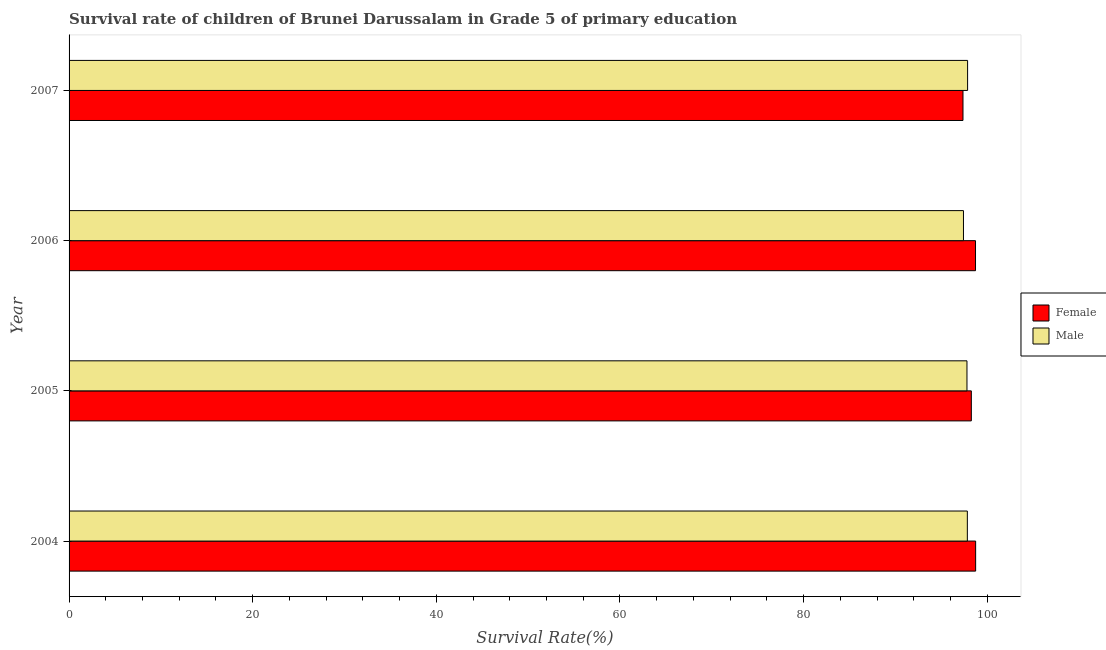How many different coloured bars are there?
Give a very brief answer. 2. In how many cases, is the number of bars for a given year not equal to the number of legend labels?
Your response must be concise. 0. What is the survival rate of female students in primary education in 2004?
Offer a very short reply. 98.74. Across all years, what is the maximum survival rate of male students in primary education?
Offer a very short reply. 97.86. Across all years, what is the minimum survival rate of female students in primary education?
Your answer should be compact. 97.36. In which year was the survival rate of male students in primary education minimum?
Make the answer very short. 2006. What is the total survival rate of male students in primary education in the graph?
Offer a terse response. 390.9. What is the difference between the survival rate of female students in primary education in 2004 and that in 2005?
Make the answer very short. 0.47. What is the difference between the survival rate of male students in primary education in 2006 and the survival rate of female students in primary education in 2005?
Make the answer very short. -0.86. What is the average survival rate of male students in primary education per year?
Give a very brief answer. 97.72. In the year 2007, what is the difference between the survival rate of female students in primary education and survival rate of male students in primary education?
Offer a very short reply. -0.5. In how many years, is the survival rate of female students in primary education greater than 84 %?
Offer a terse response. 4. What is the ratio of the survival rate of male students in primary education in 2004 to that in 2005?
Your response must be concise. 1. Is the survival rate of male students in primary education in 2006 less than that in 2007?
Your response must be concise. Yes. What is the difference between the highest and the second highest survival rate of female students in primary education?
Offer a very short reply. 0.01. What is the difference between the highest and the lowest survival rate of male students in primary education?
Your answer should be compact. 0.45. In how many years, is the survival rate of female students in primary education greater than the average survival rate of female students in primary education taken over all years?
Your answer should be compact. 2. What does the 2nd bar from the top in 2006 represents?
Ensure brevity in your answer.  Female. What does the 1st bar from the bottom in 2006 represents?
Offer a terse response. Female. How many bars are there?
Keep it short and to the point. 8. Are all the bars in the graph horizontal?
Give a very brief answer. Yes. How many years are there in the graph?
Give a very brief answer. 4. What is the difference between two consecutive major ticks on the X-axis?
Keep it short and to the point. 20. Does the graph contain grids?
Offer a terse response. No. How many legend labels are there?
Your answer should be compact. 2. What is the title of the graph?
Offer a very short reply. Survival rate of children of Brunei Darussalam in Grade 5 of primary education. Does "Secondary" appear as one of the legend labels in the graph?
Offer a terse response. No. What is the label or title of the X-axis?
Provide a succinct answer. Survival Rate(%). What is the label or title of the Y-axis?
Your answer should be very brief. Year. What is the Survival Rate(%) of Female in 2004?
Offer a terse response. 98.74. What is the Survival Rate(%) in Male in 2004?
Provide a succinct answer. 97.83. What is the Survival Rate(%) of Female in 2005?
Make the answer very short. 98.27. What is the Survival Rate(%) of Male in 2005?
Offer a very short reply. 97.79. What is the Survival Rate(%) in Female in 2006?
Provide a succinct answer. 98.72. What is the Survival Rate(%) of Male in 2006?
Your answer should be very brief. 97.41. What is the Survival Rate(%) in Female in 2007?
Your answer should be compact. 97.36. What is the Survival Rate(%) of Male in 2007?
Offer a very short reply. 97.86. Across all years, what is the maximum Survival Rate(%) in Female?
Your answer should be compact. 98.74. Across all years, what is the maximum Survival Rate(%) of Male?
Provide a succinct answer. 97.86. Across all years, what is the minimum Survival Rate(%) in Female?
Your response must be concise. 97.36. Across all years, what is the minimum Survival Rate(%) of Male?
Provide a succinct answer. 97.41. What is the total Survival Rate(%) of Female in the graph?
Your response must be concise. 393.09. What is the total Survival Rate(%) in Male in the graph?
Ensure brevity in your answer.  390.9. What is the difference between the Survival Rate(%) of Female in 2004 and that in 2005?
Provide a short and direct response. 0.47. What is the difference between the Survival Rate(%) of Male in 2004 and that in 2005?
Make the answer very short. 0.04. What is the difference between the Survival Rate(%) of Female in 2004 and that in 2006?
Offer a terse response. 0.01. What is the difference between the Survival Rate(%) in Male in 2004 and that in 2006?
Keep it short and to the point. 0.42. What is the difference between the Survival Rate(%) of Female in 2004 and that in 2007?
Offer a very short reply. 1.38. What is the difference between the Survival Rate(%) of Male in 2004 and that in 2007?
Your response must be concise. -0.03. What is the difference between the Survival Rate(%) of Female in 2005 and that in 2006?
Keep it short and to the point. -0.46. What is the difference between the Survival Rate(%) in Male in 2005 and that in 2006?
Your response must be concise. 0.38. What is the difference between the Survival Rate(%) in Female in 2005 and that in 2007?
Keep it short and to the point. 0.91. What is the difference between the Survival Rate(%) in Male in 2005 and that in 2007?
Offer a very short reply. -0.07. What is the difference between the Survival Rate(%) of Female in 2006 and that in 2007?
Provide a short and direct response. 1.37. What is the difference between the Survival Rate(%) of Male in 2006 and that in 2007?
Your answer should be very brief. -0.45. What is the difference between the Survival Rate(%) in Female in 2004 and the Survival Rate(%) in Male in 2005?
Your answer should be very brief. 0.94. What is the difference between the Survival Rate(%) in Female in 2004 and the Survival Rate(%) in Male in 2006?
Give a very brief answer. 1.33. What is the difference between the Survival Rate(%) of Female in 2004 and the Survival Rate(%) of Male in 2007?
Provide a succinct answer. 0.88. What is the difference between the Survival Rate(%) of Female in 2005 and the Survival Rate(%) of Male in 2006?
Offer a very short reply. 0.86. What is the difference between the Survival Rate(%) in Female in 2005 and the Survival Rate(%) in Male in 2007?
Offer a very short reply. 0.41. What is the difference between the Survival Rate(%) of Female in 2006 and the Survival Rate(%) of Male in 2007?
Offer a terse response. 0.86. What is the average Survival Rate(%) in Female per year?
Your answer should be very brief. 98.27. What is the average Survival Rate(%) in Male per year?
Your response must be concise. 97.73. In the year 2004, what is the difference between the Survival Rate(%) of Female and Survival Rate(%) of Male?
Offer a terse response. 0.9. In the year 2005, what is the difference between the Survival Rate(%) in Female and Survival Rate(%) in Male?
Provide a succinct answer. 0.47. In the year 2006, what is the difference between the Survival Rate(%) in Female and Survival Rate(%) in Male?
Give a very brief answer. 1.31. In the year 2007, what is the difference between the Survival Rate(%) in Female and Survival Rate(%) in Male?
Offer a terse response. -0.5. What is the ratio of the Survival Rate(%) in Female in 2004 to that in 2005?
Provide a short and direct response. 1. What is the ratio of the Survival Rate(%) in Male in 2004 to that in 2005?
Your response must be concise. 1. What is the ratio of the Survival Rate(%) in Female in 2004 to that in 2006?
Offer a terse response. 1. What is the ratio of the Survival Rate(%) of Female in 2004 to that in 2007?
Your answer should be compact. 1.01. What is the ratio of the Survival Rate(%) of Male in 2004 to that in 2007?
Give a very brief answer. 1. What is the ratio of the Survival Rate(%) in Female in 2005 to that in 2006?
Offer a very short reply. 1. What is the ratio of the Survival Rate(%) of Female in 2005 to that in 2007?
Keep it short and to the point. 1.01. What is the ratio of the Survival Rate(%) in Male in 2005 to that in 2007?
Ensure brevity in your answer.  1. What is the ratio of the Survival Rate(%) in Female in 2006 to that in 2007?
Make the answer very short. 1.01. What is the ratio of the Survival Rate(%) in Male in 2006 to that in 2007?
Make the answer very short. 1. What is the difference between the highest and the second highest Survival Rate(%) in Female?
Ensure brevity in your answer.  0.01. What is the difference between the highest and the second highest Survival Rate(%) of Male?
Your answer should be very brief. 0.03. What is the difference between the highest and the lowest Survival Rate(%) of Female?
Keep it short and to the point. 1.38. What is the difference between the highest and the lowest Survival Rate(%) in Male?
Keep it short and to the point. 0.45. 